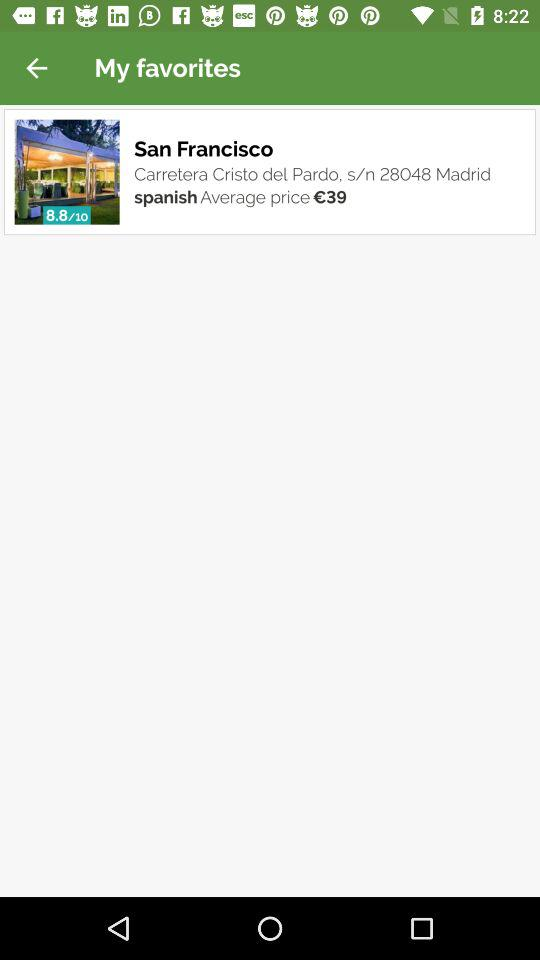What is the address?
Answer the question using a single word or phrase. The address is "Carretera Cristo del Pardo, s/n 28048 Madrid" 